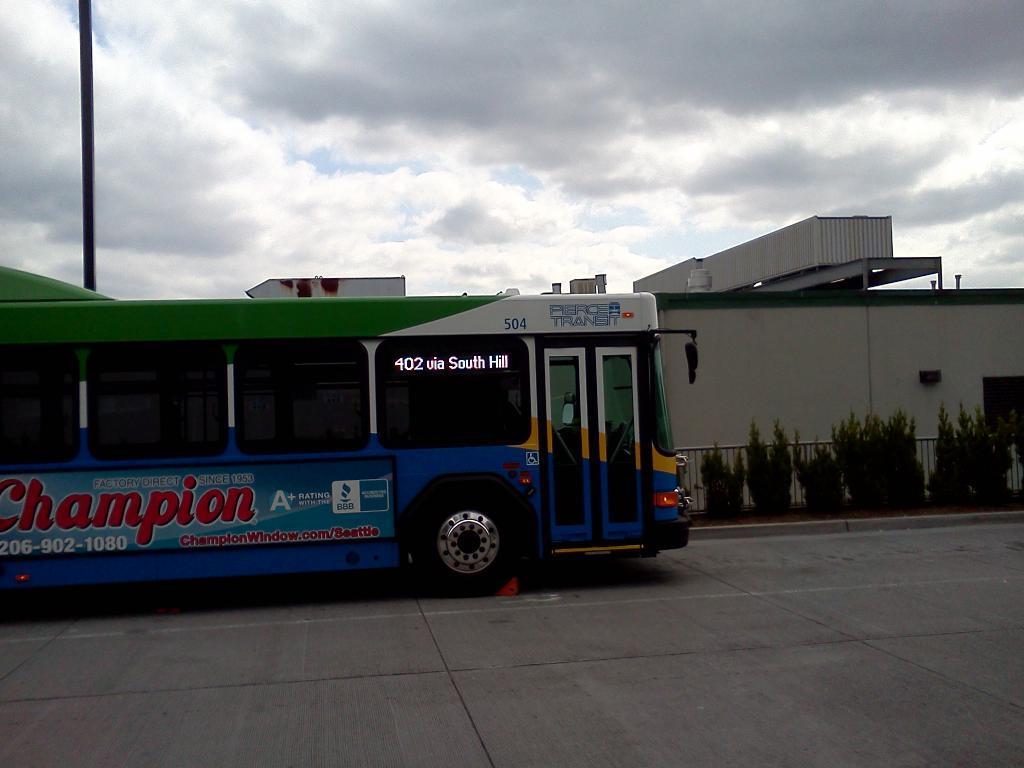How would you summarize this image in a sentence or two? There is a road in the foreground area of the image, there is a vehicle, plants, boundary, house structure, pole and the sky in the background. 